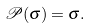<formula> <loc_0><loc_0><loc_500><loc_500>\mathcal { P } ( \sigma ) = \sigma .</formula> 